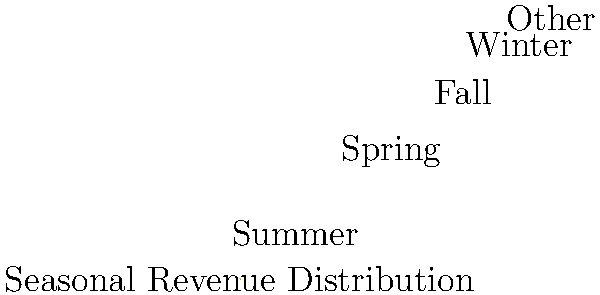Based on the pie chart showing seasonal revenue distribution for your bed and breakfast, what percentage of annual income is generated during the two most profitable seasons combined? To solve this problem, we need to follow these steps:

1. Identify the two most profitable seasons from the pie chart.
2. Add the percentages of these two seasons together.

From the pie chart, we can see that:
- Summer accounts for 35% of revenue
- Spring accounts for 25% of revenue
- Fall accounts for 20% of revenue
- Winter accounts for 15% of revenue
- Other sources account for 5% of revenue

The two most profitable seasons are Summer (35%) and Spring (25%).

To calculate the combined percentage:
$35\% + 25\% = 60\%$

Therefore, the two most profitable seasons (Summer and Spring) generate 60% of the annual income for the bed and breakfast.
Answer: 60% 